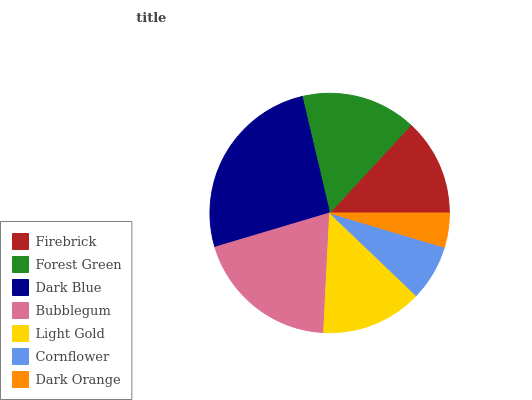Is Dark Orange the minimum?
Answer yes or no. Yes. Is Dark Blue the maximum?
Answer yes or no. Yes. Is Forest Green the minimum?
Answer yes or no. No. Is Forest Green the maximum?
Answer yes or no. No. Is Forest Green greater than Firebrick?
Answer yes or no. Yes. Is Firebrick less than Forest Green?
Answer yes or no. Yes. Is Firebrick greater than Forest Green?
Answer yes or no. No. Is Forest Green less than Firebrick?
Answer yes or no. No. Is Light Gold the high median?
Answer yes or no. Yes. Is Light Gold the low median?
Answer yes or no. Yes. Is Dark Orange the high median?
Answer yes or no. No. Is Cornflower the low median?
Answer yes or no. No. 